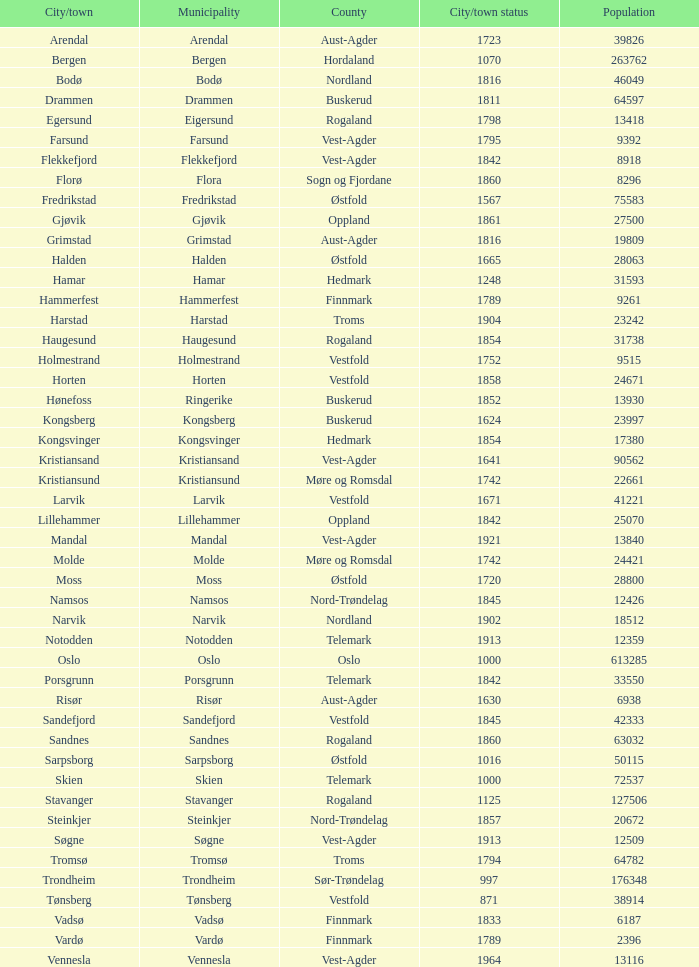What are the urban areas situated in the municipality of horten? Horten. 